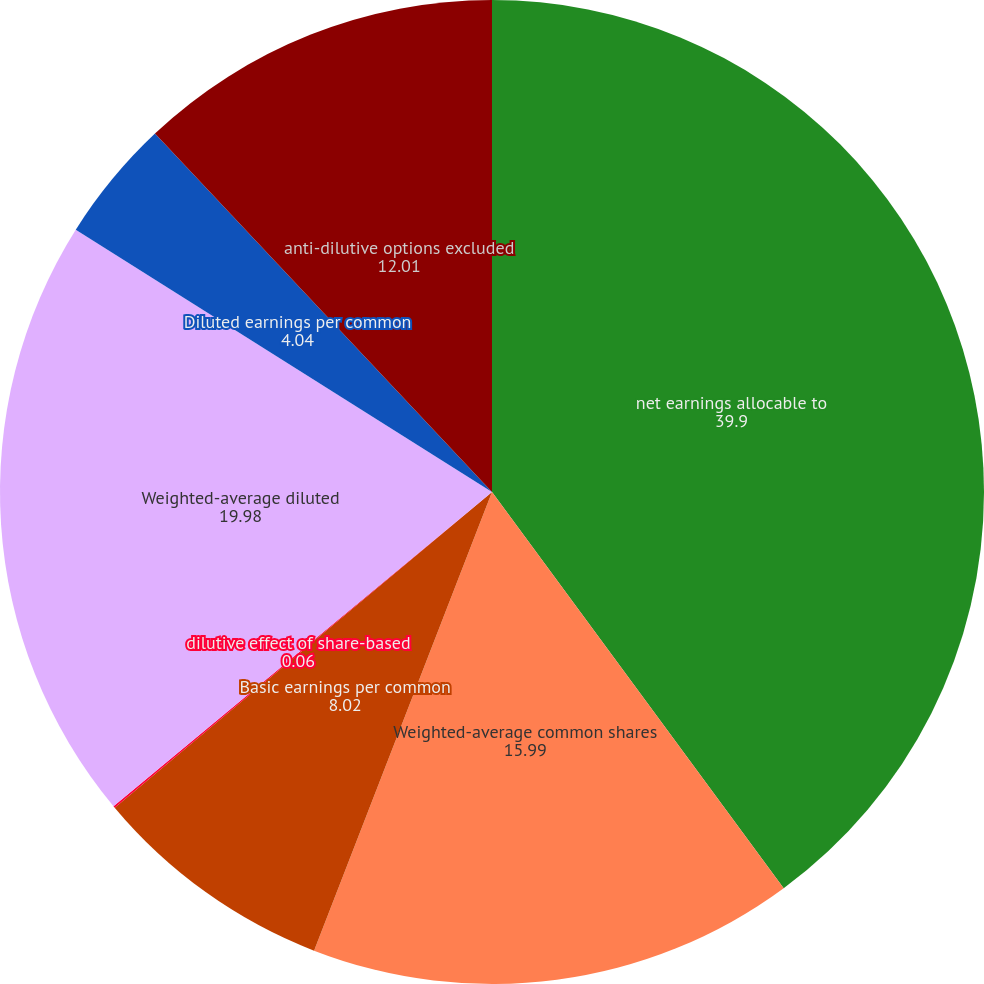<chart> <loc_0><loc_0><loc_500><loc_500><pie_chart><fcel>net earnings allocable to<fcel>Weighted-average common shares<fcel>Basic earnings per common<fcel>dilutive effect of share-based<fcel>Weighted-average diluted<fcel>Diluted earnings per common<fcel>anti-dilutive options excluded<nl><fcel>39.9%<fcel>15.99%<fcel>8.02%<fcel>0.06%<fcel>19.98%<fcel>4.04%<fcel>12.01%<nl></chart> 